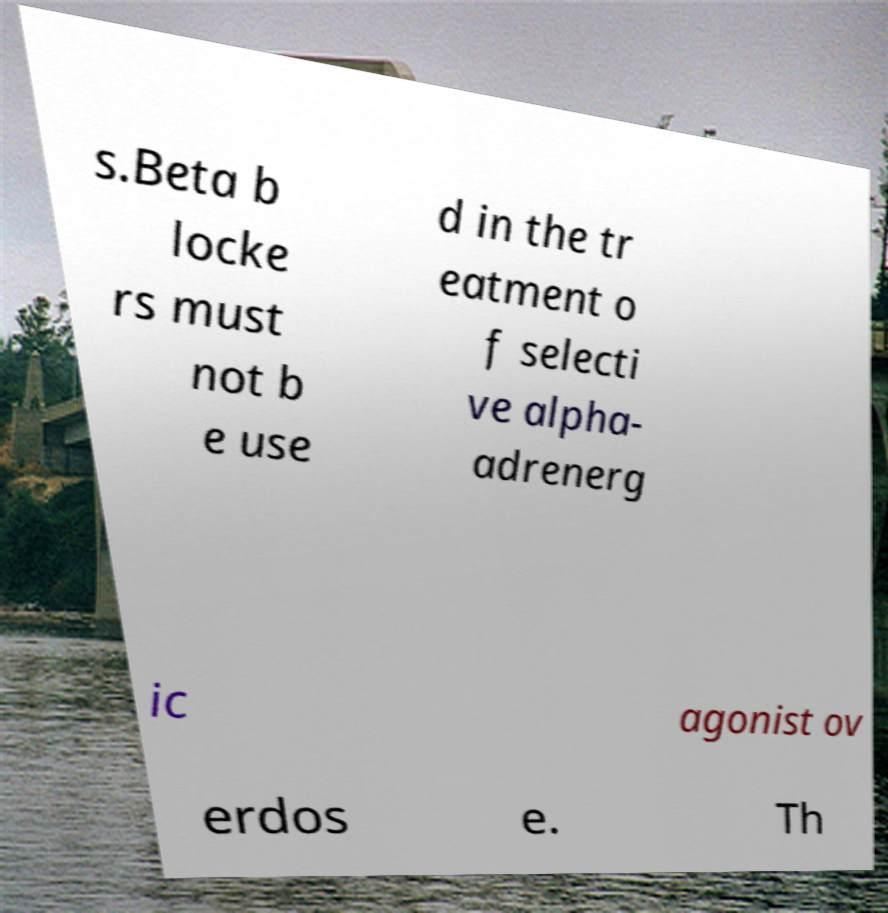Please read and relay the text visible in this image. What does it say? s.Beta b locke rs must not b e use d in the tr eatment o f selecti ve alpha- adrenerg ic agonist ov erdos e. Th 